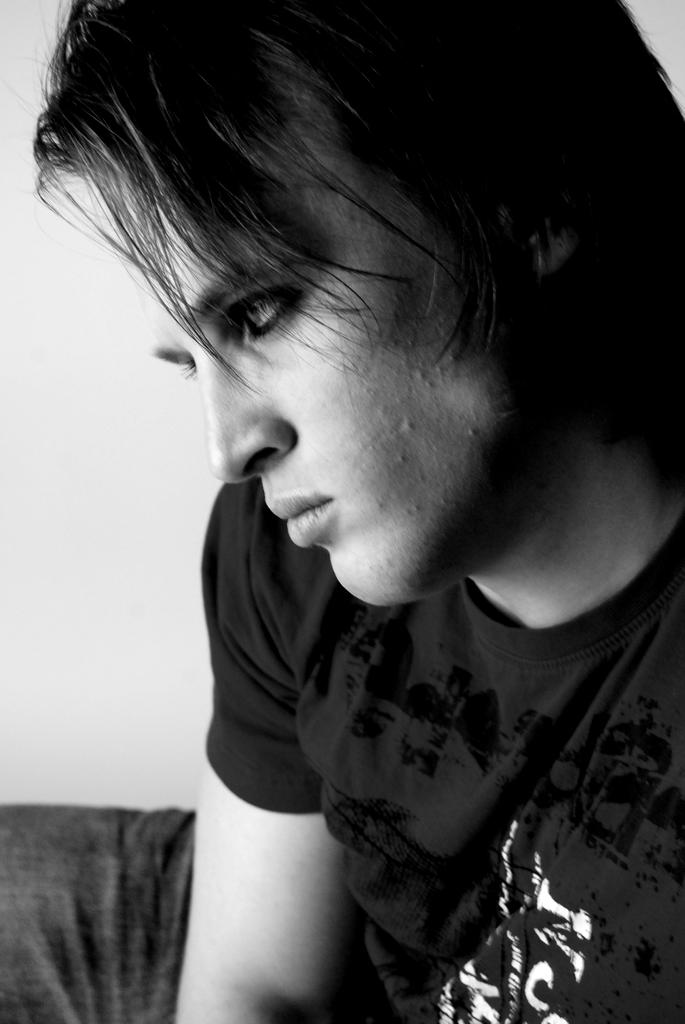Who or what is the main subject of the image? There is a person in the image. What can be seen behind the person in the image? The background of the image includes a wall. What type of hobbies does the crate in the image enjoy? There is no crate present in the image, so it is not possible to determine what hobbies it might enjoy. 